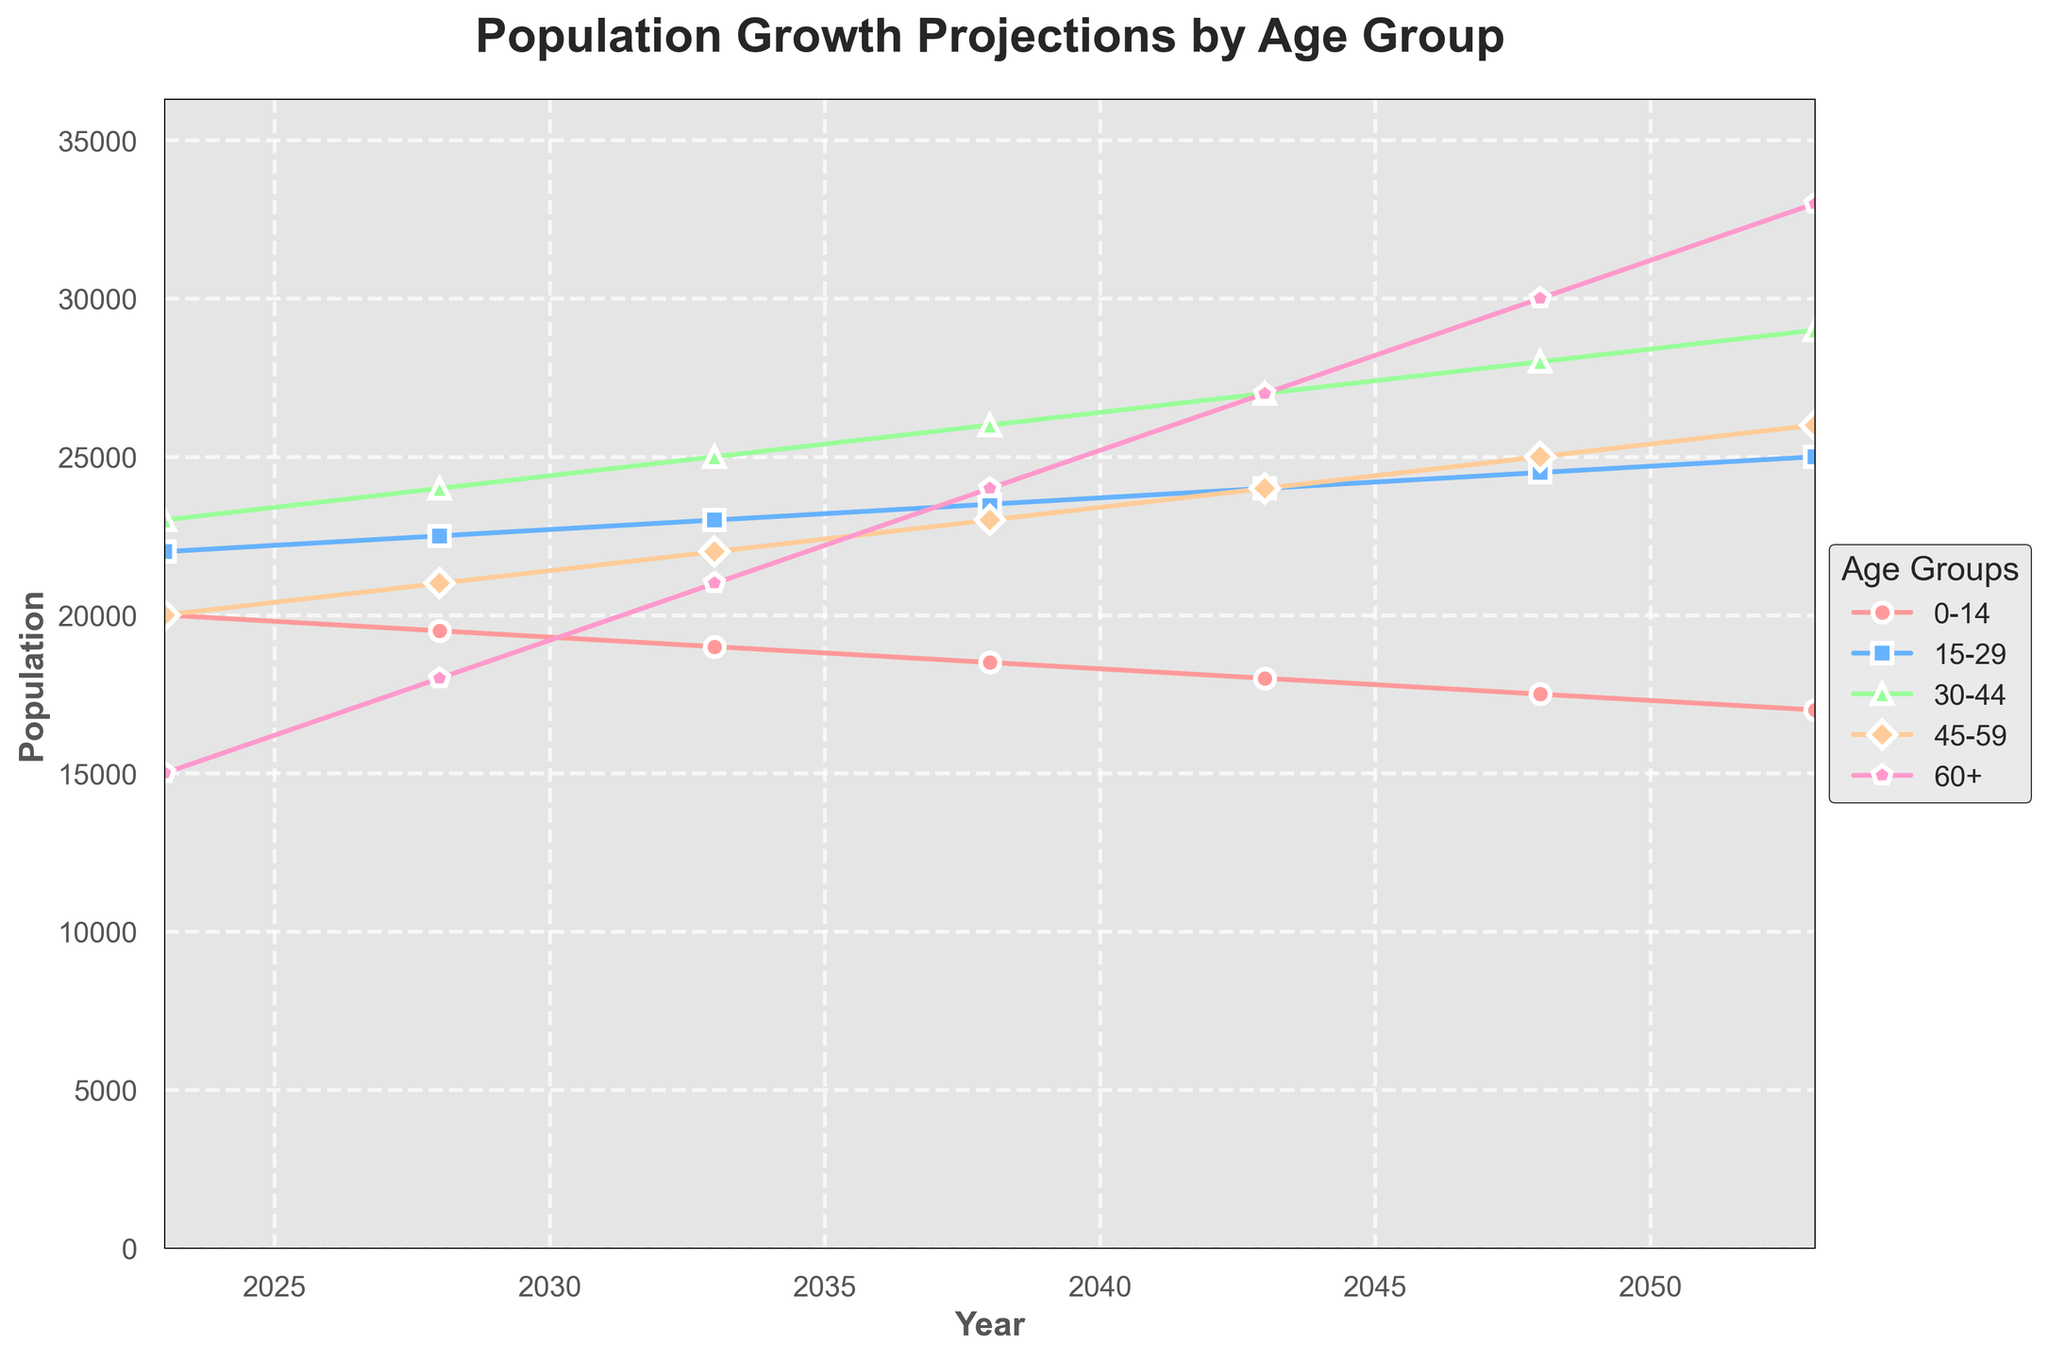**Question**: Which age group has the highest population in 2023? **Explanation**: Look at the plot for the year 2023 and compare the values of each age group. The group with the highest value is the one with the largest population.
Answer: **Answer**: 30-44 **Question**: How does the population of the 60+ age group change from 2028 to 2053? **Explanation**: Observe the values of the 60+ age group for the years 2028 and 2053. Subtract the population in 2028 from the population in 2053 to find the change.
Answer: **Answer**: +15000 **Question**: Which age group shows a decreasing trend over the years? **Explanation**: Look at the entire trend lines for all age groups from 2023 to 2053. Identify the age group whose population decreases over these years.
Answer: **Answer**: 0-14 **Question**: What is the total estimated population growth from 2023 to 2053? **Explanation**: Examine the total population values for the years 2023 and 2053. Subtract the 2023 population from the 2053 population to find the growth.
Answer: **Answer**: +30000 **Question**: Which two age groups have the same population in 2043? **Explanation**: Look at the population values for all age groups in the year 2043 and identify any values that are equal.
Answer: **Answer**: 15-29 and 45-59 **Question**: By how much does the population of the 30-44 age group increase from 2023 to 2048? **Explanation**: Check the population values for the 30-44 age group in the years 2023 and 2048. Subtract the 2023 value from the 2048 value to determine the increase.
Answer: **Answer**: +5000 **Question**: Which year sees the smallest population for the 0-14 age group? **Explanation**: Compare the population values of the 0-14 age group across all the years and identify the smallest value and its corresponding year.
Answer: **Answer**: 2053 **Question**: What is the combined population of the 45-59 and 60+ age groups in 2038? **Explanation**: Find the values of the 45-59 and 60+ age groups in 2038. Add these two values to get the combined population.
Answer: **Answer**: 47000 **Question**: Between which years does the 15-29 age group experience the highest increase in population? **Explanation**: Look at the yearly differences for the 15-29 age group's population. Identify the two years between which the difference (increase) is the greatest.
Answer: **Answer**: 2048 to 2053 